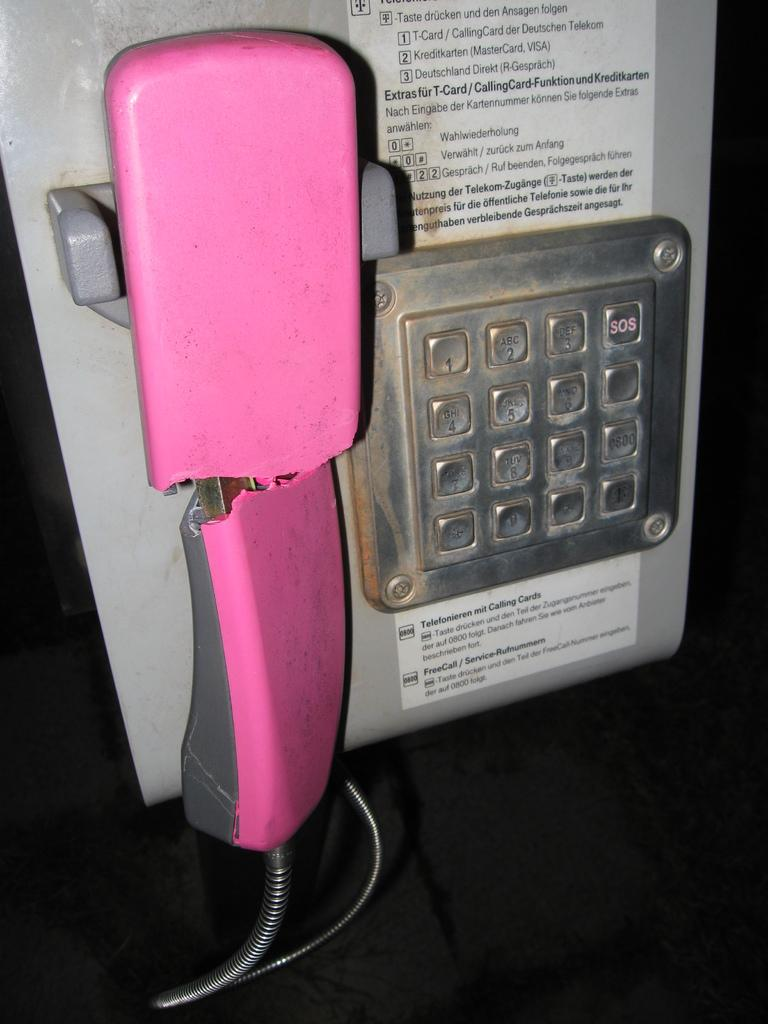What object is the main subject of the image? There is a telephone in the image in the image. What feature of the telephone is mentioned in the facts? The telephone has a cable and numbers on it. Are there any words or letters on the telephone? Yes, there is text on the telephone. How does the tiger contribute to the wealth of the person using the telephone in the image? There is no tiger present in the image, and therefore it cannot contribute to anyone's wealth. What type of discussion is taking place between the person using the telephone and the tiger in the image? There is no tiger present in the image, and no discussion can be observed. 